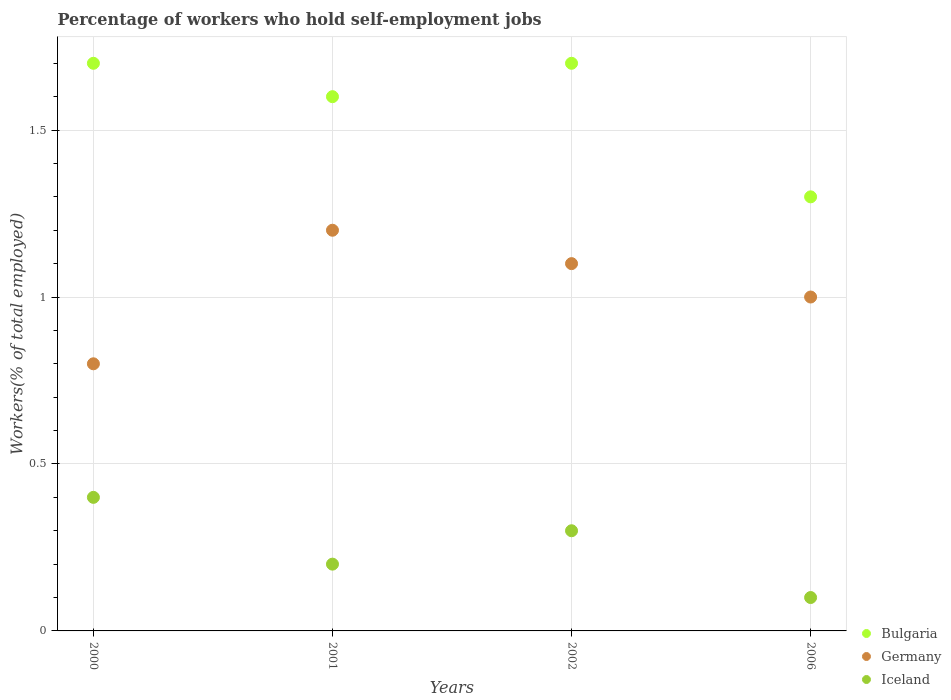How many different coloured dotlines are there?
Provide a succinct answer. 3. What is the percentage of self-employed workers in Germany in 2000?
Make the answer very short. 0.8. Across all years, what is the maximum percentage of self-employed workers in Iceland?
Your response must be concise. 0.4. Across all years, what is the minimum percentage of self-employed workers in Germany?
Make the answer very short. 0.8. In which year was the percentage of self-employed workers in Iceland minimum?
Your response must be concise. 2006. What is the total percentage of self-employed workers in Iceland in the graph?
Provide a short and direct response. 1. What is the difference between the percentage of self-employed workers in Germany in 2002 and that in 2006?
Offer a terse response. 0.1. What is the difference between the percentage of self-employed workers in Germany in 2006 and the percentage of self-employed workers in Iceland in 2002?
Provide a succinct answer. 0.7. What is the average percentage of self-employed workers in Germany per year?
Give a very brief answer. 1.03. In the year 2006, what is the difference between the percentage of self-employed workers in Iceland and percentage of self-employed workers in Germany?
Provide a short and direct response. -0.9. In how many years, is the percentage of self-employed workers in Iceland greater than 0.30000000000000004 %?
Give a very brief answer. 2. What is the ratio of the percentage of self-employed workers in Bulgaria in 2002 to that in 2006?
Provide a short and direct response. 1.31. What is the difference between the highest and the second highest percentage of self-employed workers in Iceland?
Offer a terse response. 0.1. What is the difference between the highest and the lowest percentage of self-employed workers in Bulgaria?
Offer a very short reply. 0.4. In how many years, is the percentage of self-employed workers in Bulgaria greater than the average percentage of self-employed workers in Bulgaria taken over all years?
Your response must be concise. 3. Is it the case that in every year, the sum of the percentage of self-employed workers in Iceland and percentage of self-employed workers in Germany  is greater than the percentage of self-employed workers in Bulgaria?
Your answer should be very brief. No. Does the percentage of self-employed workers in Germany monotonically increase over the years?
Provide a succinct answer. No. How many dotlines are there?
Make the answer very short. 3. How many years are there in the graph?
Provide a short and direct response. 4. Does the graph contain any zero values?
Provide a succinct answer. No. How are the legend labels stacked?
Offer a very short reply. Vertical. What is the title of the graph?
Offer a very short reply. Percentage of workers who hold self-employment jobs. Does "East Asia (all income levels)" appear as one of the legend labels in the graph?
Make the answer very short. No. What is the label or title of the Y-axis?
Provide a succinct answer. Workers(% of total employed). What is the Workers(% of total employed) in Bulgaria in 2000?
Your answer should be very brief. 1.7. What is the Workers(% of total employed) in Germany in 2000?
Keep it short and to the point. 0.8. What is the Workers(% of total employed) in Iceland in 2000?
Your response must be concise. 0.4. What is the Workers(% of total employed) of Bulgaria in 2001?
Offer a very short reply. 1.6. What is the Workers(% of total employed) of Germany in 2001?
Provide a succinct answer. 1.2. What is the Workers(% of total employed) of Iceland in 2001?
Your answer should be compact. 0.2. What is the Workers(% of total employed) in Bulgaria in 2002?
Your answer should be compact. 1.7. What is the Workers(% of total employed) of Germany in 2002?
Make the answer very short. 1.1. What is the Workers(% of total employed) in Iceland in 2002?
Offer a very short reply. 0.3. What is the Workers(% of total employed) in Bulgaria in 2006?
Give a very brief answer. 1.3. What is the Workers(% of total employed) of Iceland in 2006?
Keep it short and to the point. 0.1. Across all years, what is the maximum Workers(% of total employed) in Bulgaria?
Offer a terse response. 1.7. Across all years, what is the maximum Workers(% of total employed) of Germany?
Keep it short and to the point. 1.2. Across all years, what is the maximum Workers(% of total employed) of Iceland?
Offer a terse response. 0.4. Across all years, what is the minimum Workers(% of total employed) of Bulgaria?
Your answer should be compact. 1.3. Across all years, what is the minimum Workers(% of total employed) in Germany?
Your answer should be very brief. 0.8. Across all years, what is the minimum Workers(% of total employed) of Iceland?
Keep it short and to the point. 0.1. What is the total Workers(% of total employed) in Iceland in the graph?
Ensure brevity in your answer.  1. What is the difference between the Workers(% of total employed) of Germany in 2000 and that in 2001?
Give a very brief answer. -0.4. What is the difference between the Workers(% of total employed) of Iceland in 2000 and that in 2001?
Your answer should be very brief. 0.2. What is the difference between the Workers(% of total employed) in Bulgaria in 2000 and that in 2002?
Give a very brief answer. 0. What is the difference between the Workers(% of total employed) in Germany in 2000 and that in 2002?
Ensure brevity in your answer.  -0.3. What is the difference between the Workers(% of total employed) of Iceland in 2000 and that in 2002?
Offer a very short reply. 0.1. What is the difference between the Workers(% of total employed) in Germany in 2000 and that in 2006?
Offer a very short reply. -0.2. What is the difference between the Workers(% of total employed) of Iceland in 2000 and that in 2006?
Keep it short and to the point. 0.3. What is the difference between the Workers(% of total employed) of Bulgaria in 2001 and that in 2002?
Offer a very short reply. -0.1. What is the difference between the Workers(% of total employed) of Iceland in 2001 and that in 2002?
Keep it short and to the point. -0.1. What is the difference between the Workers(% of total employed) of Iceland in 2001 and that in 2006?
Offer a terse response. 0.1. What is the difference between the Workers(% of total employed) of Iceland in 2002 and that in 2006?
Provide a short and direct response. 0.2. What is the difference between the Workers(% of total employed) of Bulgaria in 2000 and the Workers(% of total employed) of Iceland in 2001?
Provide a succinct answer. 1.5. What is the difference between the Workers(% of total employed) in Germany in 2000 and the Workers(% of total employed) in Iceland in 2001?
Offer a very short reply. 0.6. What is the difference between the Workers(% of total employed) in Bulgaria in 2000 and the Workers(% of total employed) in Germany in 2002?
Offer a very short reply. 0.6. What is the difference between the Workers(% of total employed) of Bulgaria in 2000 and the Workers(% of total employed) of Iceland in 2002?
Provide a short and direct response. 1.4. What is the difference between the Workers(% of total employed) in Bulgaria in 2001 and the Workers(% of total employed) in Iceland in 2002?
Provide a short and direct response. 1.3. What is the difference between the Workers(% of total employed) of Bulgaria in 2002 and the Workers(% of total employed) of Germany in 2006?
Your response must be concise. 0.7. What is the difference between the Workers(% of total employed) of Bulgaria in 2002 and the Workers(% of total employed) of Iceland in 2006?
Give a very brief answer. 1.6. What is the difference between the Workers(% of total employed) in Germany in 2002 and the Workers(% of total employed) in Iceland in 2006?
Keep it short and to the point. 1. What is the average Workers(% of total employed) of Bulgaria per year?
Offer a terse response. 1.57. What is the average Workers(% of total employed) in Germany per year?
Provide a short and direct response. 1.02. What is the average Workers(% of total employed) in Iceland per year?
Your answer should be compact. 0.25. In the year 2000, what is the difference between the Workers(% of total employed) of Germany and Workers(% of total employed) of Iceland?
Your response must be concise. 0.4. In the year 2006, what is the difference between the Workers(% of total employed) in Bulgaria and Workers(% of total employed) in Germany?
Ensure brevity in your answer.  0.3. In the year 2006, what is the difference between the Workers(% of total employed) in Bulgaria and Workers(% of total employed) in Iceland?
Your answer should be very brief. 1.2. In the year 2006, what is the difference between the Workers(% of total employed) in Germany and Workers(% of total employed) in Iceland?
Provide a succinct answer. 0.9. What is the ratio of the Workers(% of total employed) of Bulgaria in 2000 to that in 2002?
Your answer should be compact. 1. What is the ratio of the Workers(% of total employed) of Germany in 2000 to that in 2002?
Keep it short and to the point. 0.73. What is the ratio of the Workers(% of total employed) in Iceland in 2000 to that in 2002?
Make the answer very short. 1.33. What is the ratio of the Workers(% of total employed) in Bulgaria in 2000 to that in 2006?
Your answer should be compact. 1.31. What is the ratio of the Workers(% of total employed) of Germany in 2000 to that in 2006?
Keep it short and to the point. 0.8. What is the ratio of the Workers(% of total employed) of Iceland in 2000 to that in 2006?
Ensure brevity in your answer.  4. What is the ratio of the Workers(% of total employed) of Germany in 2001 to that in 2002?
Provide a short and direct response. 1.09. What is the ratio of the Workers(% of total employed) of Iceland in 2001 to that in 2002?
Ensure brevity in your answer.  0.67. What is the ratio of the Workers(% of total employed) of Bulgaria in 2001 to that in 2006?
Your response must be concise. 1.23. What is the ratio of the Workers(% of total employed) of Germany in 2001 to that in 2006?
Provide a succinct answer. 1.2. What is the ratio of the Workers(% of total employed) in Iceland in 2001 to that in 2006?
Give a very brief answer. 2. What is the ratio of the Workers(% of total employed) in Bulgaria in 2002 to that in 2006?
Offer a very short reply. 1.31. What is the ratio of the Workers(% of total employed) in Iceland in 2002 to that in 2006?
Give a very brief answer. 3. What is the difference between the highest and the second highest Workers(% of total employed) in Germany?
Keep it short and to the point. 0.1. What is the difference between the highest and the lowest Workers(% of total employed) in Germany?
Ensure brevity in your answer.  0.4. What is the difference between the highest and the lowest Workers(% of total employed) in Iceland?
Make the answer very short. 0.3. 